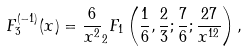Convert formula to latex. <formula><loc_0><loc_0><loc_500><loc_500>F _ { 3 } ^ { ( - 1 ) } ( x ) = \frac { 6 } { x ^ { 2 } } _ { 2 } F _ { 1 } \left ( \frac { 1 } { 6 } , \frac { 2 } { 3 } ; \frac { 7 } { 6 } ; \frac { 2 7 } { x ^ { 1 2 } } \right ) ,</formula> 